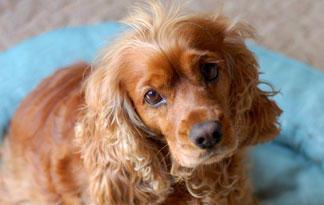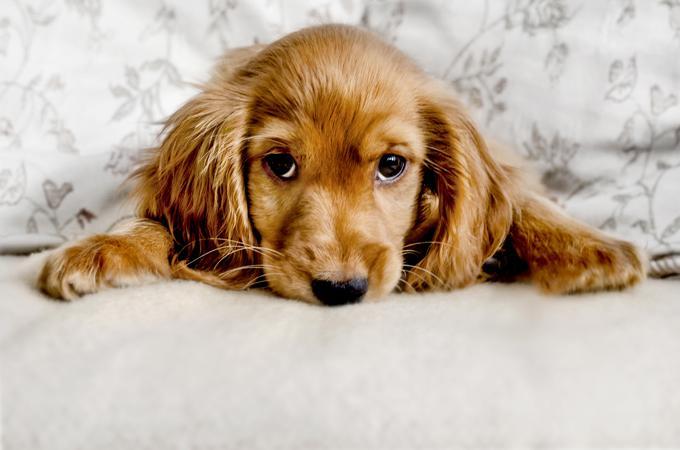The first image is the image on the left, the second image is the image on the right. Examine the images to the left and right. Is the description "One dog is on the grass, surrounded by grass." accurate? Answer yes or no. No. 